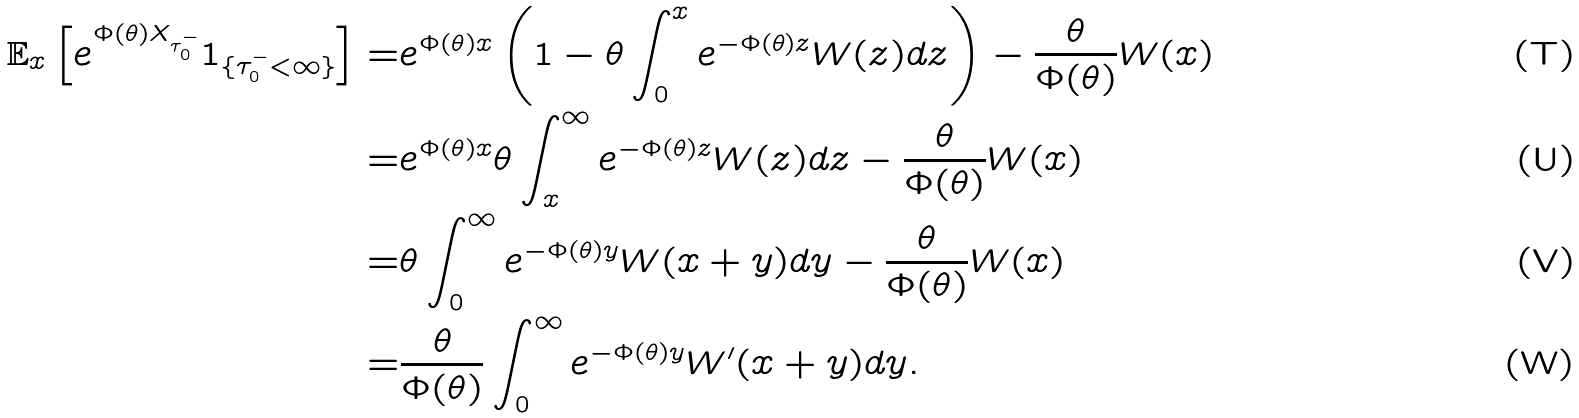Convert formula to latex. <formula><loc_0><loc_0><loc_500><loc_500>\mathbb { E } _ { x } \left [ e ^ { \Phi ( \theta ) X _ { \tau _ { 0 } ^ { - } } } 1 _ { \{ \tau _ { 0 } ^ { - } < \infty \} } \right ] = & e ^ { \Phi ( \theta ) x } \left ( 1 - \theta \int _ { 0 } ^ { x } e ^ { - \Phi ( \theta ) z } W ( z ) d z \right ) - \frac { \theta } { \Phi ( \theta ) } W ( x ) \\ = & e ^ { \Phi ( \theta ) x } \theta \int _ { x } ^ { \infty } e ^ { - \Phi ( \theta ) z } W ( z ) d z - \frac { \theta } { \Phi ( \theta ) } W ( x ) \\ = & \theta \int _ { 0 } ^ { \infty } e ^ { - \Phi ( \theta ) y } W ( x + y ) d y - \frac { \theta } { \Phi ( \theta ) } W ( x ) \\ = & \frac { \theta } { \Phi ( \theta ) } \int _ { 0 } ^ { \infty } e ^ { - \Phi ( \theta ) y } W ^ { \prime } ( x + y ) d y .</formula> 